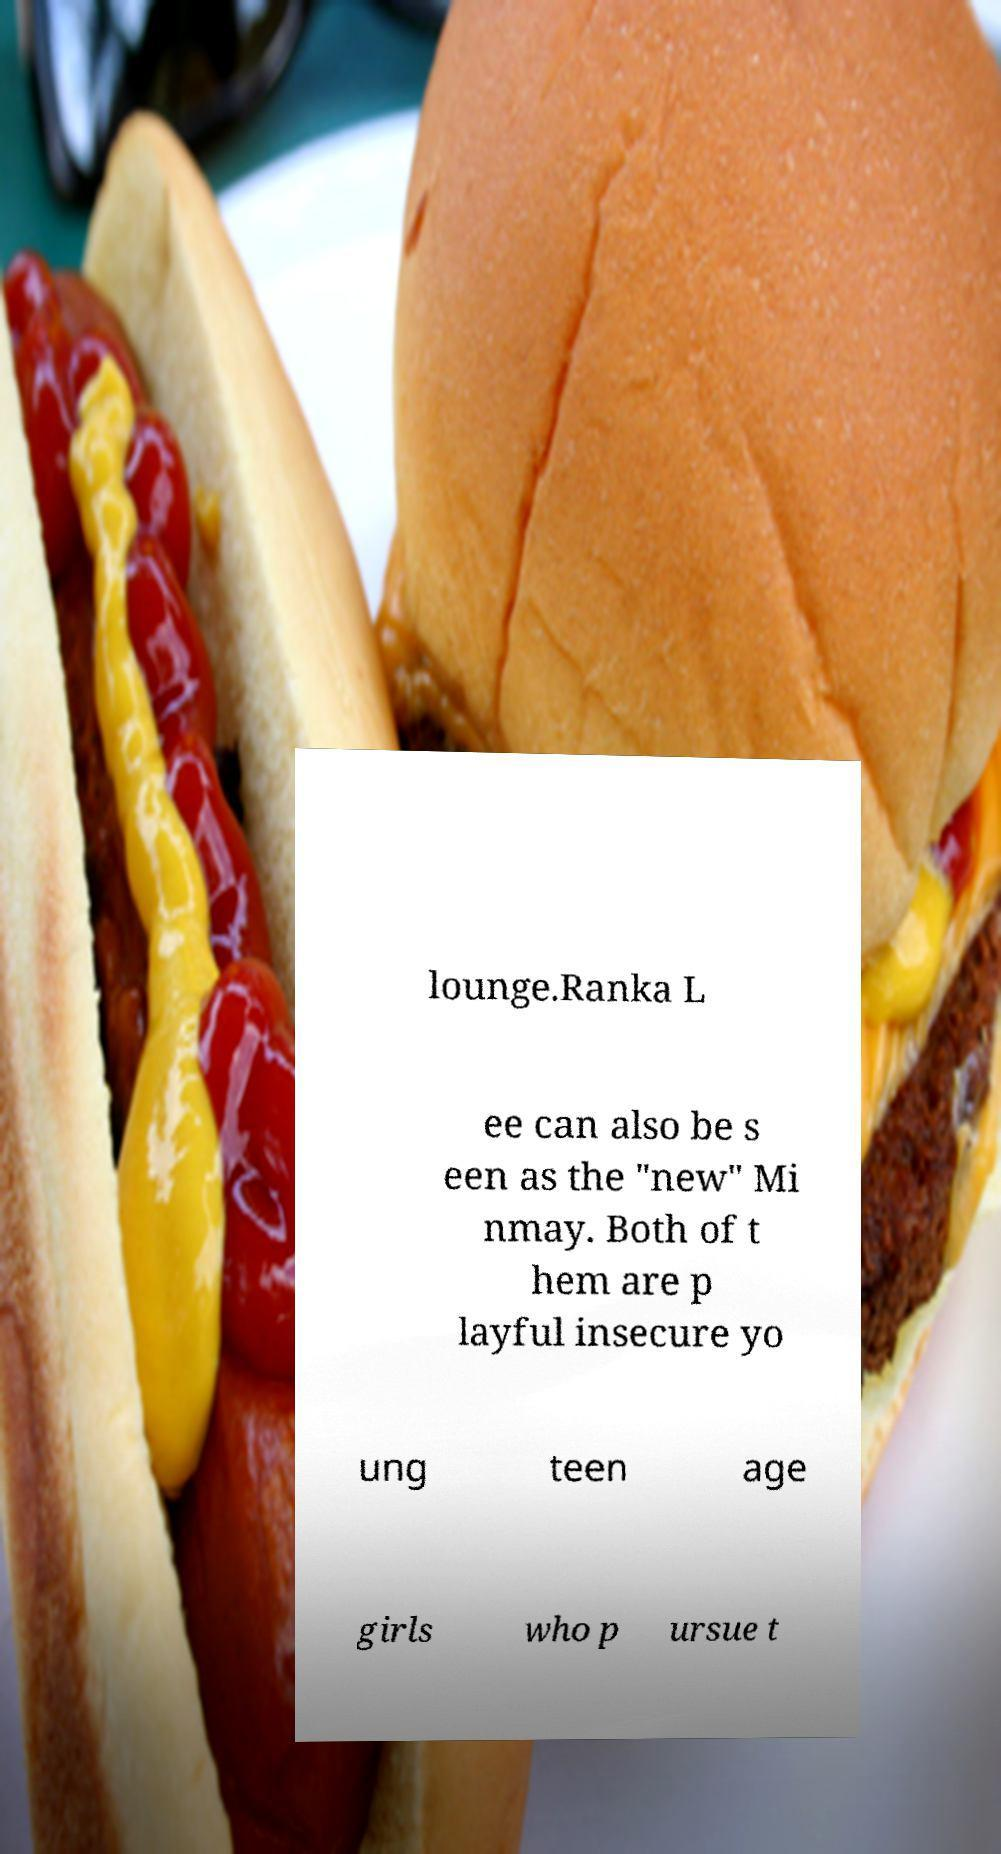Can you read and provide the text displayed in the image?This photo seems to have some interesting text. Can you extract and type it out for me? lounge.Ranka L ee can also be s een as the "new" Mi nmay. Both of t hem are p layful insecure yo ung teen age girls who p ursue t 